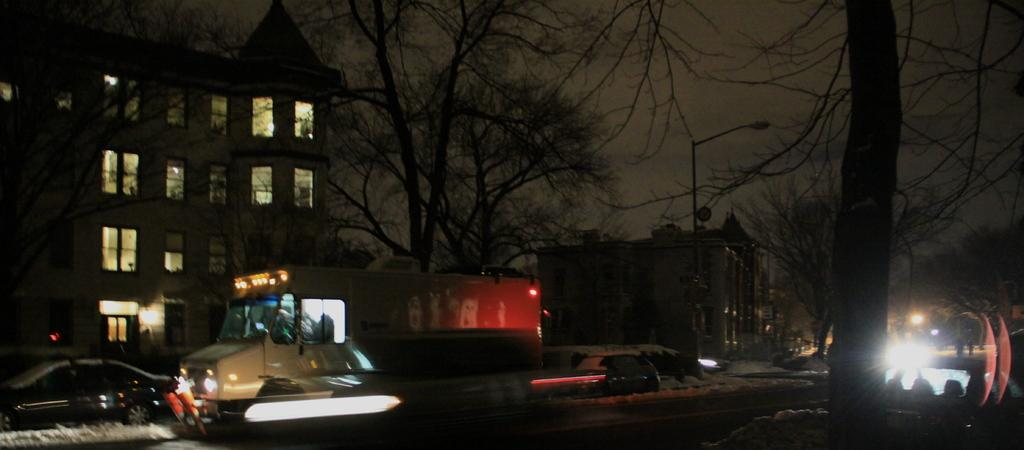What can be seen on the road in the image? There are vehicles on the road in the image. What is located on the right side of the image? There is a street light on the right side of the image. What type of natural elements can be seen in the background of the image? There are trees in the background of the image. What type of man-made structures can be seen in the background of the image? There are buildings in the background of the image. What is visible at the top of the image? The sky is visible at the top of the image. What type of sea creature can be seen on the page in the image? There is no sea creature or page present in the image; it features vehicles on a road with a street light, trees, buildings, and the sky. 